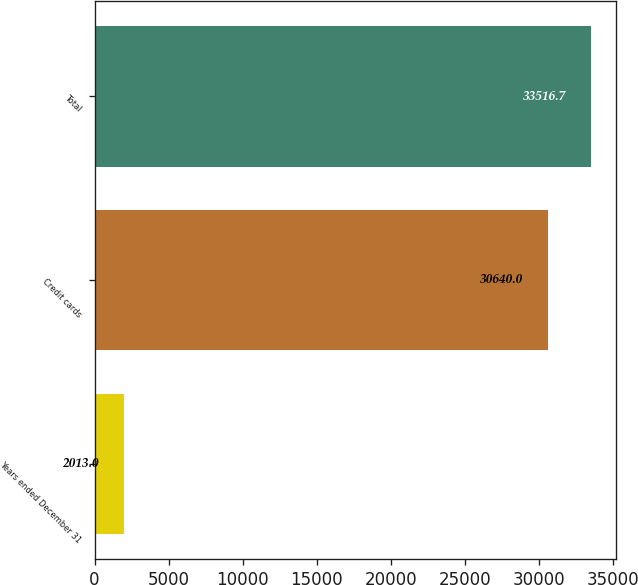Convert chart. <chart><loc_0><loc_0><loc_500><loc_500><bar_chart><fcel>Years ended December 31<fcel>Credit cards<fcel>Total<nl><fcel>2013<fcel>30640<fcel>33516.7<nl></chart> 